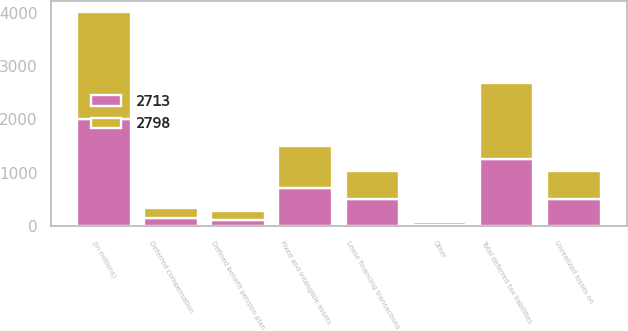Convert chart to OTSL. <chart><loc_0><loc_0><loc_500><loc_500><stacked_bar_chart><ecel><fcel>(In millions)<fcel>Lease financing transactions<fcel>Fixed and intangible assets<fcel>Other<fcel>Total deferred tax liabilities<fcel>Unrealized losses on<fcel>Deferred compensation<fcel>Defined benefit pension plan<nl><fcel>2713<fcel>2009<fcel>505<fcel>725<fcel>30<fcel>1260<fcel>520<fcel>165<fcel>124<nl><fcel>2798<fcel>2008<fcel>535<fcel>775<fcel>51<fcel>1424<fcel>520<fcel>172<fcel>169<nl></chart> 